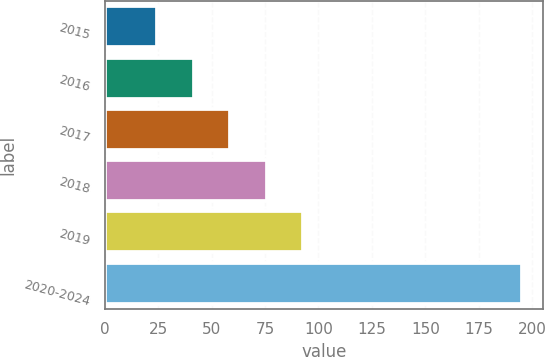Convert chart to OTSL. <chart><loc_0><loc_0><loc_500><loc_500><bar_chart><fcel>2015<fcel>2016<fcel>2017<fcel>2018<fcel>2019<fcel>2020-2024<nl><fcel>24.5<fcel>41.59<fcel>58.68<fcel>75.77<fcel>92.86<fcel>195.4<nl></chart> 